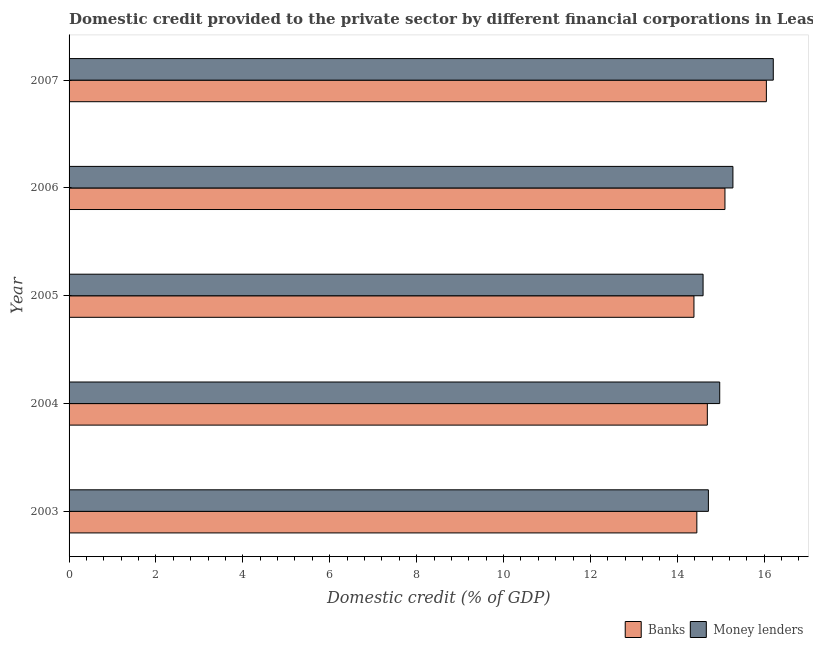How many different coloured bars are there?
Your answer should be very brief. 2. How many bars are there on the 2nd tick from the top?
Provide a succinct answer. 2. What is the domestic credit provided by banks in 2006?
Ensure brevity in your answer.  15.1. Across all years, what is the maximum domestic credit provided by banks?
Your answer should be very brief. 16.05. Across all years, what is the minimum domestic credit provided by banks?
Your answer should be very brief. 14.38. In which year was the domestic credit provided by money lenders maximum?
Ensure brevity in your answer.  2007. In which year was the domestic credit provided by banks minimum?
Provide a short and direct response. 2005. What is the total domestic credit provided by banks in the graph?
Offer a very short reply. 74.67. What is the difference between the domestic credit provided by banks in 2004 and that in 2005?
Make the answer very short. 0.31. What is the difference between the domestic credit provided by banks in 2004 and the domestic credit provided by money lenders in 2003?
Ensure brevity in your answer.  -0.02. What is the average domestic credit provided by banks per year?
Make the answer very short. 14.93. In the year 2005, what is the difference between the domestic credit provided by banks and domestic credit provided by money lenders?
Make the answer very short. -0.21. In how many years, is the domestic credit provided by banks greater than 13.2 %?
Your answer should be very brief. 5. What is the ratio of the domestic credit provided by money lenders in 2004 to that in 2005?
Ensure brevity in your answer.  1.03. What is the difference between the highest and the second highest domestic credit provided by money lenders?
Ensure brevity in your answer.  0.93. What is the difference between the highest and the lowest domestic credit provided by banks?
Your answer should be compact. 1.67. In how many years, is the domestic credit provided by banks greater than the average domestic credit provided by banks taken over all years?
Provide a succinct answer. 2. Is the sum of the domestic credit provided by money lenders in 2003 and 2006 greater than the maximum domestic credit provided by banks across all years?
Make the answer very short. Yes. What does the 2nd bar from the top in 2007 represents?
Provide a succinct answer. Banks. What does the 2nd bar from the bottom in 2006 represents?
Offer a very short reply. Money lenders. How many years are there in the graph?
Offer a very short reply. 5. Does the graph contain grids?
Give a very brief answer. No. Where does the legend appear in the graph?
Offer a very short reply. Bottom right. How many legend labels are there?
Give a very brief answer. 2. What is the title of the graph?
Give a very brief answer. Domestic credit provided to the private sector by different financial corporations in Least developed countries. Does "Overweight" appear as one of the legend labels in the graph?
Offer a very short reply. No. What is the label or title of the X-axis?
Ensure brevity in your answer.  Domestic credit (% of GDP). What is the Domestic credit (% of GDP) in Banks in 2003?
Offer a terse response. 14.45. What is the Domestic credit (% of GDP) in Money lenders in 2003?
Make the answer very short. 14.72. What is the Domestic credit (% of GDP) of Banks in 2004?
Make the answer very short. 14.69. What is the Domestic credit (% of GDP) in Money lenders in 2004?
Keep it short and to the point. 14.98. What is the Domestic credit (% of GDP) of Banks in 2005?
Provide a short and direct response. 14.38. What is the Domestic credit (% of GDP) of Money lenders in 2005?
Offer a very short reply. 14.59. What is the Domestic credit (% of GDP) in Banks in 2006?
Make the answer very short. 15.1. What is the Domestic credit (% of GDP) in Money lenders in 2006?
Your answer should be very brief. 15.28. What is the Domestic credit (% of GDP) of Banks in 2007?
Give a very brief answer. 16.05. What is the Domestic credit (% of GDP) in Money lenders in 2007?
Your answer should be compact. 16.21. Across all years, what is the maximum Domestic credit (% of GDP) of Banks?
Provide a short and direct response. 16.05. Across all years, what is the maximum Domestic credit (% of GDP) in Money lenders?
Give a very brief answer. 16.21. Across all years, what is the minimum Domestic credit (% of GDP) in Banks?
Offer a very short reply. 14.38. Across all years, what is the minimum Domestic credit (% of GDP) in Money lenders?
Ensure brevity in your answer.  14.59. What is the total Domestic credit (% of GDP) in Banks in the graph?
Give a very brief answer. 74.67. What is the total Domestic credit (% of GDP) in Money lenders in the graph?
Offer a terse response. 75.78. What is the difference between the Domestic credit (% of GDP) of Banks in 2003 and that in 2004?
Make the answer very short. -0.24. What is the difference between the Domestic credit (% of GDP) in Money lenders in 2003 and that in 2004?
Offer a very short reply. -0.26. What is the difference between the Domestic credit (% of GDP) in Banks in 2003 and that in 2005?
Make the answer very short. 0.07. What is the difference between the Domestic credit (% of GDP) of Money lenders in 2003 and that in 2005?
Offer a terse response. 0.12. What is the difference between the Domestic credit (% of GDP) in Banks in 2003 and that in 2006?
Keep it short and to the point. -0.65. What is the difference between the Domestic credit (% of GDP) in Money lenders in 2003 and that in 2006?
Your response must be concise. -0.56. What is the difference between the Domestic credit (% of GDP) of Banks in 2003 and that in 2007?
Provide a succinct answer. -1.6. What is the difference between the Domestic credit (% of GDP) of Money lenders in 2003 and that in 2007?
Offer a very short reply. -1.49. What is the difference between the Domestic credit (% of GDP) in Banks in 2004 and that in 2005?
Offer a very short reply. 0.31. What is the difference between the Domestic credit (% of GDP) of Money lenders in 2004 and that in 2005?
Keep it short and to the point. 0.38. What is the difference between the Domestic credit (% of GDP) in Banks in 2004 and that in 2006?
Your answer should be very brief. -0.41. What is the difference between the Domestic credit (% of GDP) in Money lenders in 2004 and that in 2006?
Your answer should be compact. -0.3. What is the difference between the Domestic credit (% of GDP) of Banks in 2004 and that in 2007?
Your answer should be compact. -1.36. What is the difference between the Domestic credit (% of GDP) of Money lenders in 2004 and that in 2007?
Your response must be concise. -1.23. What is the difference between the Domestic credit (% of GDP) of Banks in 2005 and that in 2006?
Keep it short and to the point. -0.71. What is the difference between the Domestic credit (% of GDP) of Money lenders in 2005 and that in 2006?
Keep it short and to the point. -0.69. What is the difference between the Domestic credit (% of GDP) in Banks in 2005 and that in 2007?
Ensure brevity in your answer.  -1.67. What is the difference between the Domestic credit (% of GDP) in Money lenders in 2005 and that in 2007?
Make the answer very short. -1.62. What is the difference between the Domestic credit (% of GDP) of Banks in 2006 and that in 2007?
Give a very brief answer. -0.95. What is the difference between the Domestic credit (% of GDP) of Money lenders in 2006 and that in 2007?
Provide a short and direct response. -0.93. What is the difference between the Domestic credit (% of GDP) of Banks in 2003 and the Domestic credit (% of GDP) of Money lenders in 2004?
Offer a very short reply. -0.53. What is the difference between the Domestic credit (% of GDP) of Banks in 2003 and the Domestic credit (% of GDP) of Money lenders in 2005?
Provide a succinct answer. -0.14. What is the difference between the Domestic credit (% of GDP) of Banks in 2003 and the Domestic credit (% of GDP) of Money lenders in 2006?
Your response must be concise. -0.83. What is the difference between the Domestic credit (% of GDP) in Banks in 2003 and the Domestic credit (% of GDP) in Money lenders in 2007?
Offer a very short reply. -1.76. What is the difference between the Domestic credit (% of GDP) in Banks in 2004 and the Domestic credit (% of GDP) in Money lenders in 2005?
Your answer should be very brief. 0.1. What is the difference between the Domestic credit (% of GDP) of Banks in 2004 and the Domestic credit (% of GDP) of Money lenders in 2006?
Your answer should be compact. -0.59. What is the difference between the Domestic credit (% of GDP) in Banks in 2004 and the Domestic credit (% of GDP) in Money lenders in 2007?
Ensure brevity in your answer.  -1.52. What is the difference between the Domestic credit (% of GDP) of Banks in 2005 and the Domestic credit (% of GDP) of Money lenders in 2006?
Your answer should be very brief. -0.9. What is the difference between the Domestic credit (% of GDP) in Banks in 2005 and the Domestic credit (% of GDP) in Money lenders in 2007?
Give a very brief answer. -1.83. What is the difference between the Domestic credit (% of GDP) in Banks in 2006 and the Domestic credit (% of GDP) in Money lenders in 2007?
Make the answer very short. -1.11. What is the average Domestic credit (% of GDP) in Banks per year?
Your answer should be compact. 14.93. What is the average Domestic credit (% of GDP) of Money lenders per year?
Offer a very short reply. 15.16. In the year 2003, what is the difference between the Domestic credit (% of GDP) of Banks and Domestic credit (% of GDP) of Money lenders?
Your response must be concise. -0.27. In the year 2004, what is the difference between the Domestic credit (% of GDP) in Banks and Domestic credit (% of GDP) in Money lenders?
Offer a terse response. -0.29. In the year 2005, what is the difference between the Domestic credit (% of GDP) of Banks and Domestic credit (% of GDP) of Money lenders?
Give a very brief answer. -0.21. In the year 2006, what is the difference between the Domestic credit (% of GDP) in Banks and Domestic credit (% of GDP) in Money lenders?
Ensure brevity in your answer.  -0.18. In the year 2007, what is the difference between the Domestic credit (% of GDP) in Banks and Domestic credit (% of GDP) in Money lenders?
Keep it short and to the point. -0.16. What is the ratio of the Domestic credit (% of GDP) in Banks in 2003 to that in 2004?
Make the answer very short. 0.98. What is the ratio of the Domestic credit (% of GDP) in Money lenders in 2003 to that in 2004?
Ensure brevity in your answer.  0.98. What is the ratio of the Domestic credit (% of GDP) of Banks in 2003 to that in 2005?
Give a very brief answer. 1. What is the ratio of the Domestic credit (% of GDP) in Money lenders in 2003 to that in 2005?
Your answer should be very brief. 1.01. What is the ratio of the Domestic credit (% of GDP) of Banks in 2003 to that in 2006?
Provide a short and direct response. 0.96. What is the ratio of the Domestic credit (% of GDP) in Money lenders in 2003 to that in 2006?
Offer a very short reply. 0.96. What is the ratio of the Domestic credit (% of GDP) of Banks in 2003 to that in 2007?
Your answer should be compact. 0.9. What is the ratio of the Domestic credit (% of GDP) in Money lenders in 2003 to that in 2007?
Your response must be concise. 0.91. What is the ratio of the Domestic credit (% of GDP) of Banks in 2004 to that in 2005?
Provide a succinct answer. 1.02. What is the ratio of the Domestic credit (% of GDP) in Money lenders in 2004 to that in 2005?
Make the answer very short. 1.03. What is the ratio of the Domestic credit (% of GDP) of Banks in 2004 to that in 2006?
Your answer should be very brief. 0.97. What is the ratio of the Domestic credit (% of GDP) of Money lenders in 2004 to that in 2006?
Ensure brevity in your answer.  0.98. What is the ratio of the Domestic credit (% of GDP) in Banks in 2004 to that in 2007?
Make the answer very short. 0.92. What is the ratio of the Domestic credit (% of GDP) in Money lenders in 2004 to that in 2007?
Your answer should be very brief. 0.92. What is the ratio of the Domestic credit (% of GDP) of Banks in 2005 to that in 2006?
Ensure brevity in your answer.  0.95. What is the ratio of the Domestic credit (% of GDP) in Money lenders in 2005 to that in 2006?
Make the answer very short. 0.95. What is the ratio of the Domestic credit (% of GDP) in Banks in 2005 to that in 2007?
Offer a terse response. 0.9. What is the ratio of the Domestic credit (% of GDP) in Money lenders in 2005 to that in 2007?
Offer a very short reply. 0.9. What is the ratio of the Domestic credit (% of GDP) in Banks in 2006 to that in 2007?
Keep it short and to the point. 0.94. What is the ratio of the Domestic credit (% of GDP) in Money lenders in 2006 to that in 2007?
Your answer should be very brief. 0.94. What is the difference between the highest and the second highest Domestic credit (% of GDP) of Banks?
Offer a terse response. 0.95. What is the difference between the highest and the second highest Domestic credit (% of GDP) in Money lenders?
Keep it short and to the point. 0.93. What is the difference between the highest and the lowest Domestic credit (% of GDP) in Banks?
Give a very brief answer. 1.67. What is the difference between the highest and the lowest Domestic credit (% of GDP) in Money lenders?
Ensure brevity in your answer.  1.62. 